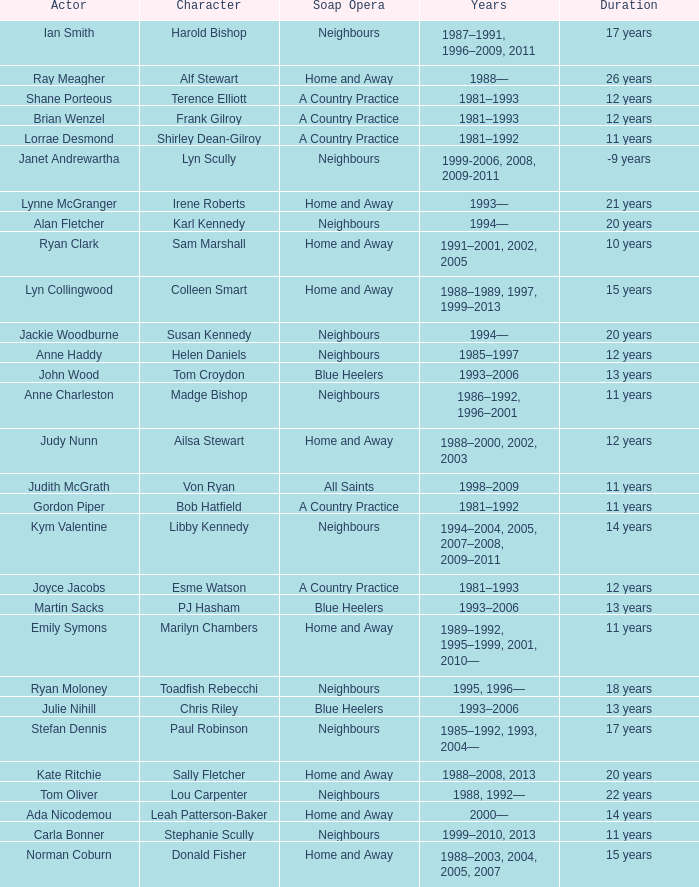Give me the full table as a dictionary. {'header': ['Actor', 'Character', 'Soap Opera', 'Years', 'Duration'], 'rows': [['Ian Smith', 'Harold Bishop', 'Neighbours', '1987–1991, 1996–2009, 2011', '17 years'], ['Ray Meagher', 'Alf Stewart', 'Home and Away', '1988—', '26 years'], ['Shane Porteous', 'Terence Elliott', 'A Country Practice', '1981–1993', '12 years'], ['Brian Wenzel', 'Frank Gilroy', 'A Country Practice', '1981–1993', '12 years'], ['Lorrae Desmond', 'Shirley Dean-Gilroy', 'A Country Practice', '1981–1992', '11 years'], ['Janet Andrewartha', 'Lyn Scully', 'Neighbours', '1999-2006, 2008, 2009-2011', '-9 years'], ['Lynne McGranger', 'Irene Roberts', 'Home and Away', '1993—', '21 years'], ['Alan Fletcher', 'Karl Kennedy', 'Neighbours', '1994—', '20 years'], ['Ryan Clark', 'Sam Marshall', 'Home and Away', '1991–2001, 2002, 2005', '10 years'], ['Lyn Collingwood', 'Colleen Smart', 'Home and Away', '1988–1989, 1997, 1999–2013', '15 years'], ['Jackie Woodburne', 'Susan Kennedy', 'Neighbours', '1994—', '20 years'], ['Anne Haddy', 'Helen Daniels', 'Neighbours', '1985–1997', '12 years'], ['John Wood', 'Tom Croydon', 'Blue Heelers', '1993–2006', '13 years'], ['Anne Charleston', 'Madge Bishop', 'Neighbours', '1986–1992, 1996–2001', '11 years'], ['Judy Nunn', 'Ailsa Stewart', 'Home and Away', '1988–2000, 2002, 2003', '12 years'], ['Judith McGrath', 'Von Ryan', 'All Saints', '1998–2009', '11 years'], ['Gordon Piper', 'Bob Hatfield', 'A Country Practice', '1981–1992', '11 years'], ['Kym Valentine', 'Libby Kennedy', 'Neighbours', '1994–2004, 2005, 2007–2008, 2009–2011', '14 years'], ['Joyce Jacobs', 'Esme Watson', 'A Country Practice', '1981–1993', '12 years'], ['Martin Sacks', 'PJ Hasham', 'Blue Heelers', '1993–2006', '13 years'], ['Emily Symons', 'Marilyn Chambers', 'Home and Away', '1989–1992, 1995–1999, 2001, 2010—', '11 years'], ['Ryan Moloney', 'Toadfish Rebecchi', 'Neighbours', '1995, 1996—', '18 years'], ['Julie Nihill', 'Chris Riley', 'Blue Heelers', '1993–2006', '13 years'], ['Stefan Dennis', 'Paul Robinson', 'Neighbours', '1985–1992, 1993, 2004—', '17 years'], ['Kate Ritchie', 'Sally Fletcher', 'Home and Away', '1988–2008, 2013', '20 years'], ['Tom Oliver', 'Lou Carpenter', 'Neighbours', '1988, 1992—', '22 years'], ['Ada Nicodemou', 'Leah Patterson-Baker', 'Home and Away', '2000—', '14 years'], ['Carla Bonner', 'Stephanie Scully', 'Neighbours', '1999–2010, 2013', '11 years'], ['Norman Coburn', 'Donald Fisher', 'Home and Away', '1988–2003, 2004, 2005, 2007', '15 years']]} How long did Joyce Jacobs portray her character on her show? 12 years. 